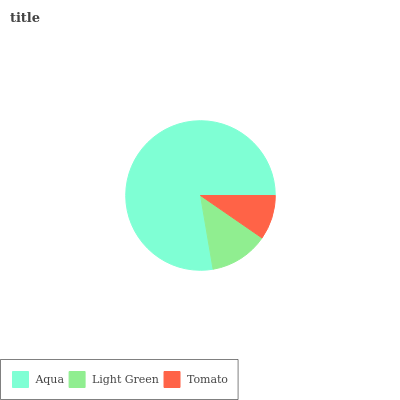Is Tomato the minimum?
Answer yes or no. Yes. Is Aqua the maximum?
Answer yes or no. Yes. Is Light Green the minimum?
Answer yes or no. No. Is Light Green the maximum?
Answer yes or no. No. Is Aqua greater than Light Green?
Answer yes or no. Yes. Is Light Green less than Aqua?
Answer yes or no. Yes. Is Light Green greater than Aqua?
Answer yes or no. No. Is Aqua less than Light Green?
Answer yes or no. No. Is Light Green the high median?
Answer yes or no. Yes. Is Light Green the low median?
Answer yes or no. Yes. Is Aqua the high median?
Answer yes or no. No. Is Tomato the low median?
Answer yes or no. No. 